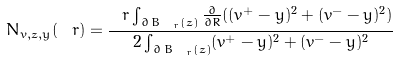<formula> <loc_0><loc_0><loc_500><loc_500>N _ { v , z , y } ( \ r ) = \frac { \ r \int _ { \partial \, B _ { \ r } ( z ) } \frac { \partial } { \partial R } ( ( v ^ { + } - y ) ^ { 2 } + ( v ^ { - } - y ) ^ { 2 } ) } { 2 \int _ { \partial \, B _ { \ r } ( z ) } ( v ^ { + } - y ) ^ { 2 } + ( v ^ { - } - y ) ^ { 2 } }</formula> 